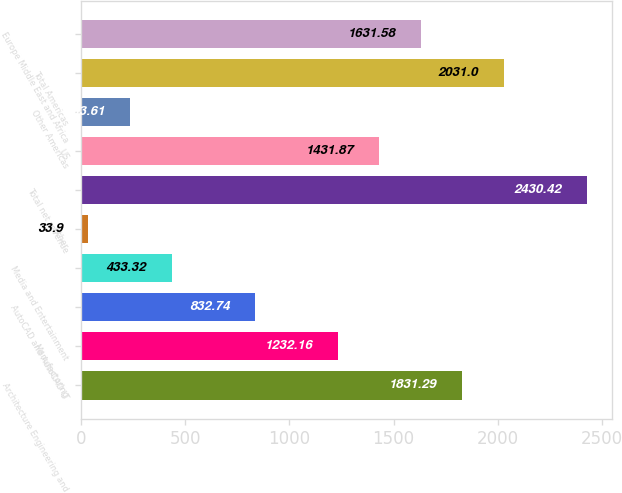Convert chart to OTSL. <chart><loc_0><loc_0><loc_500><loc_500><bar_chart><fcel>Architecture Engineering and<fcel>Manufacturing<fcel>AutoCAD and AutoCAD LT<fcel>Media and Entertainment<fcel>Other<fcel>Total net revenue<fcel>US<fcel>Other Americas<fcel>Total Americas<fcel>Europe Middle East and Africa<nl><fcel>1831.29<fcel>1232.16<fcel>832.74<fcel>433.32<fcel>33.9<fcel>2430.42<fcel>1431.87<fcel>233.61<fcel>2031<fcel>1631.58<nl></chart> 